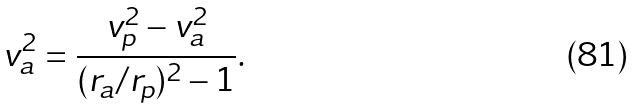<formula> <loc_0><loc_0><loc_500><loc_500>v _ { a } ^ { 2 } = \frac { v _ { p } ^ { 2 } - v _ { a } ^ { 2 } } { ( r _ { a } / r _ { p } ) ^ { 2 } - 1 } .</formula> 